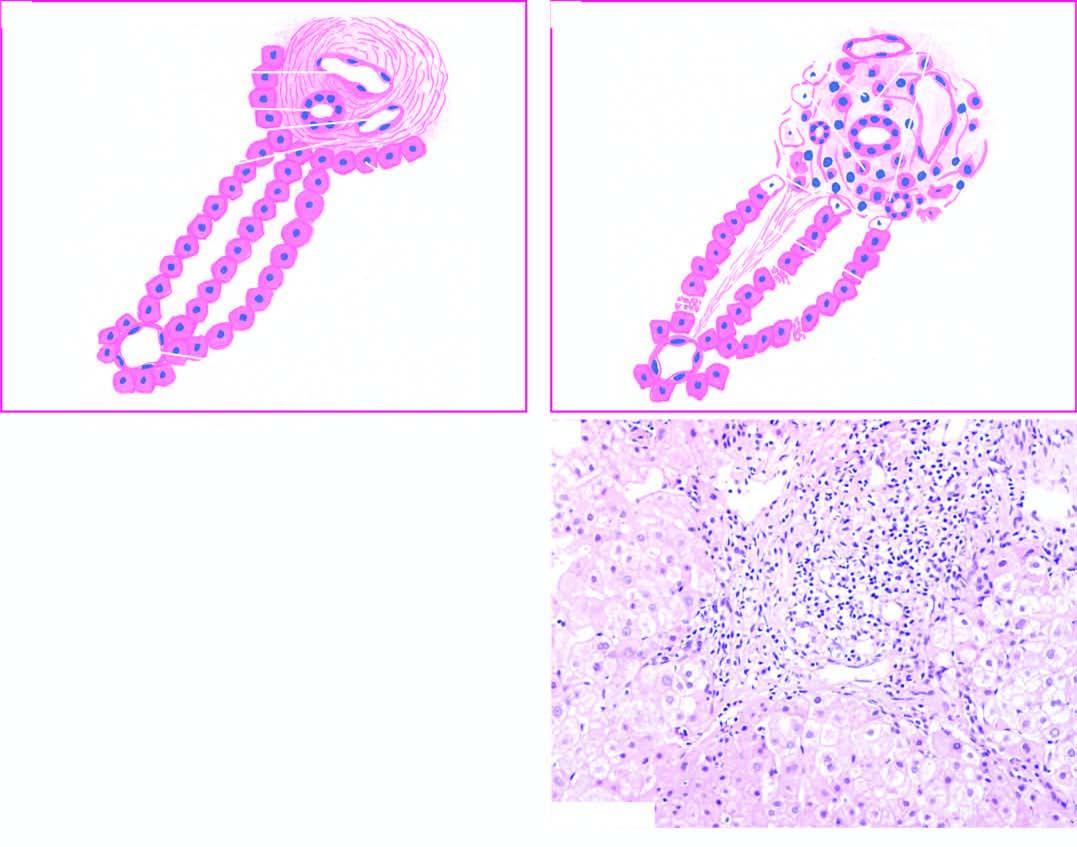what is diagrammatic representation of pathologic changes in chronic hepatitis contrasted with?
Answer the question using a single word or phrase. Normal morphology 